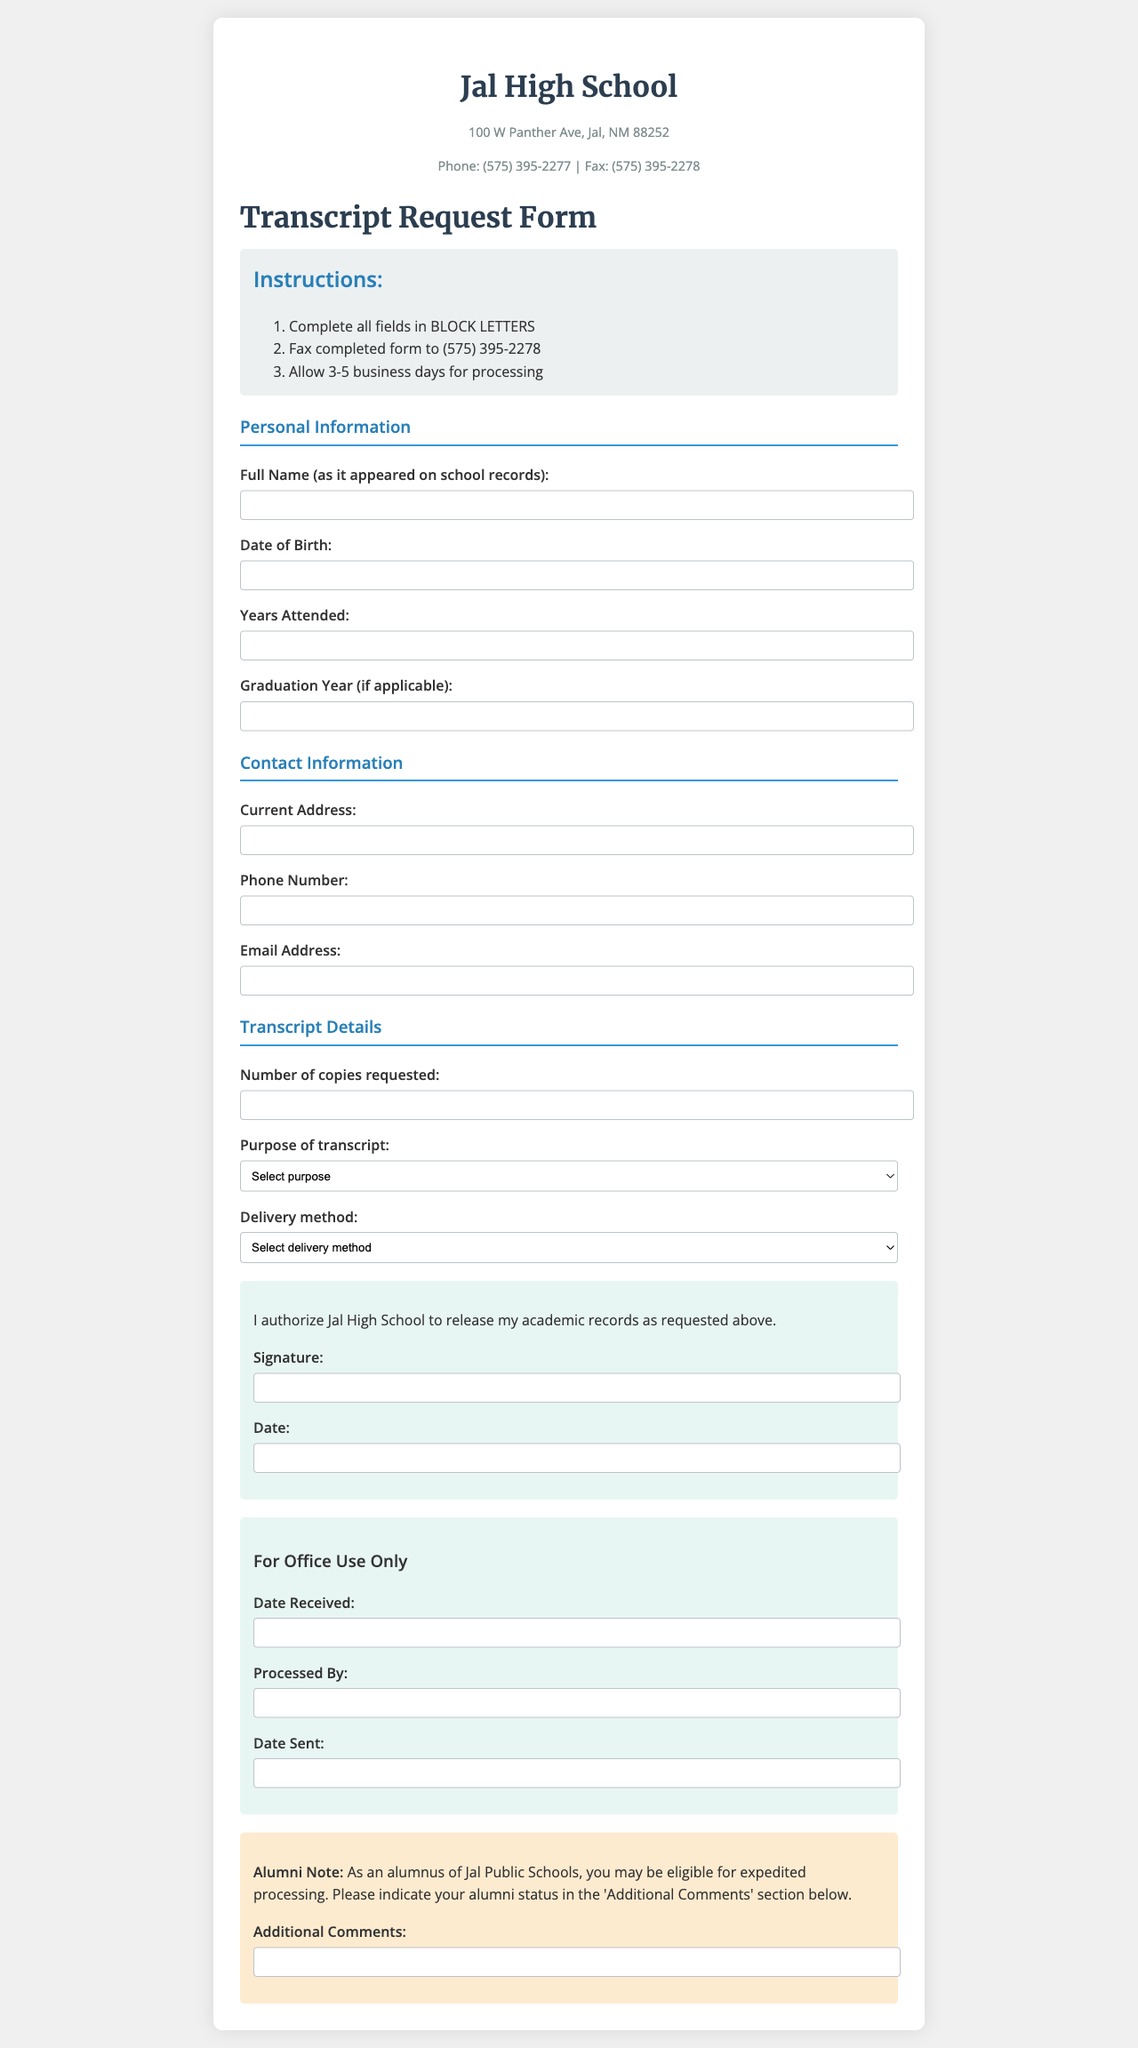What is the address of Jal High School? The address is provided in the header of the document.
Answer: 100 W Panther Ave, Jal, NM 88252 What is the fax number for Jal High School? The fax number is listed alongside the phone number in the contact information.
Answer: (575) 395-2278 How many business days should you allow for processing the transcript request? The instructions specify the processing time.
Answer: 3-5 business days What is required in the 'Full Name' field? The document states that the full name should be as it appeared on school records.
Answer: As it appeared on school records What is the purpose of the transcript? The document provides multiple options within the form; the required response is mentioned in the dropdown list.
Answer: College application, Employment, Personal records What must you do before faxing the completed form? The instructions list an essential step for completing the form.
Answer: Complete all fields in BLOCK LETTERS What can be included in the 'Additional Comments' section? The alumni note suggests mentioning one's alumni status for expedited processing in that section.
Answer: Alumni status Who processes the transcript requests in the school? The document indicates a section dedicated to office processing but does not name specific individuals.
Answer: Processed By What are the available delivery methods for the transcript? The document provides options for how the transcript can be sent; these are selectable in the form.
Answer: Mail to address provided, Pick up in person, Send to specific institution What must be included in the authorization section of the form? The authorization section requires a signature and date as indicated in the form group.
Answer: Signature and Date 